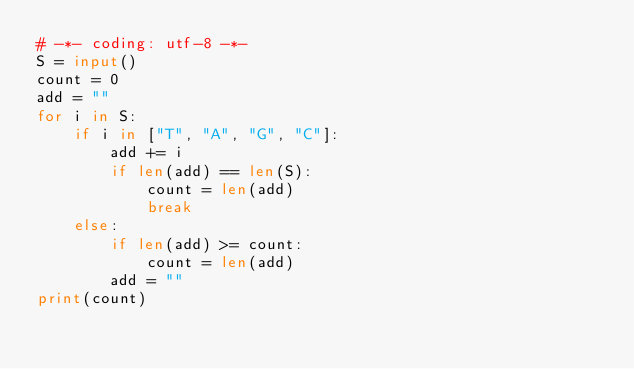<code> <loc_0><loc_0><loc_500><loc_500><_Python_># -*- coding: utf-8 -*-
S = input()
count = 0
add = ""
for i in S:
    if i in ["T", "A", "G", "C"]:
        add += i
        if len(add) == len(S):
            count = len(add)
            break
    else:
        if len(add) >= count:
            count = len(add)
        add = ""
print(count)
</code> 